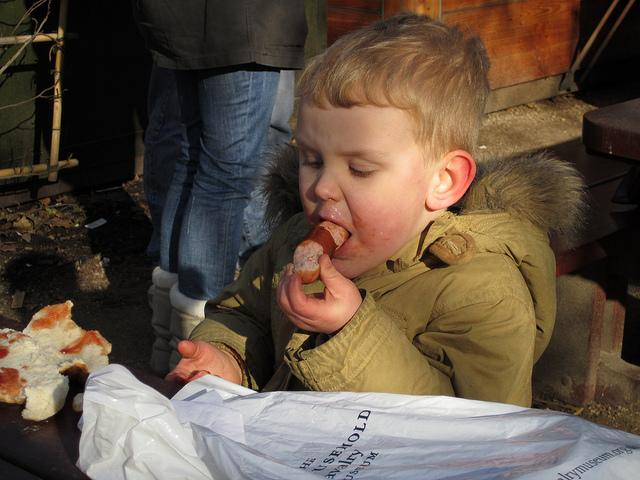Why is the food eaten by the boy unhealthy? Please explain your reasoning. high sodium. The food is a sausage.  salt is used, often in large quantities, to make sausage.  salt contains a lot of a specific element. 